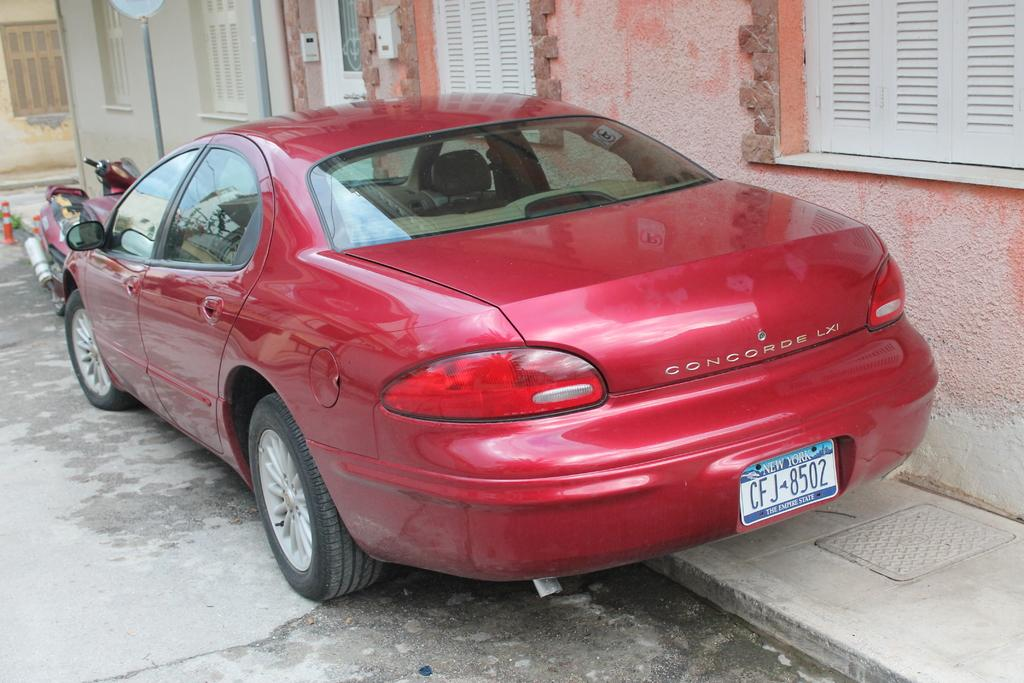Provide a one-sentence caption for the provided image. A red car with the word Concorde on the back of fit. 